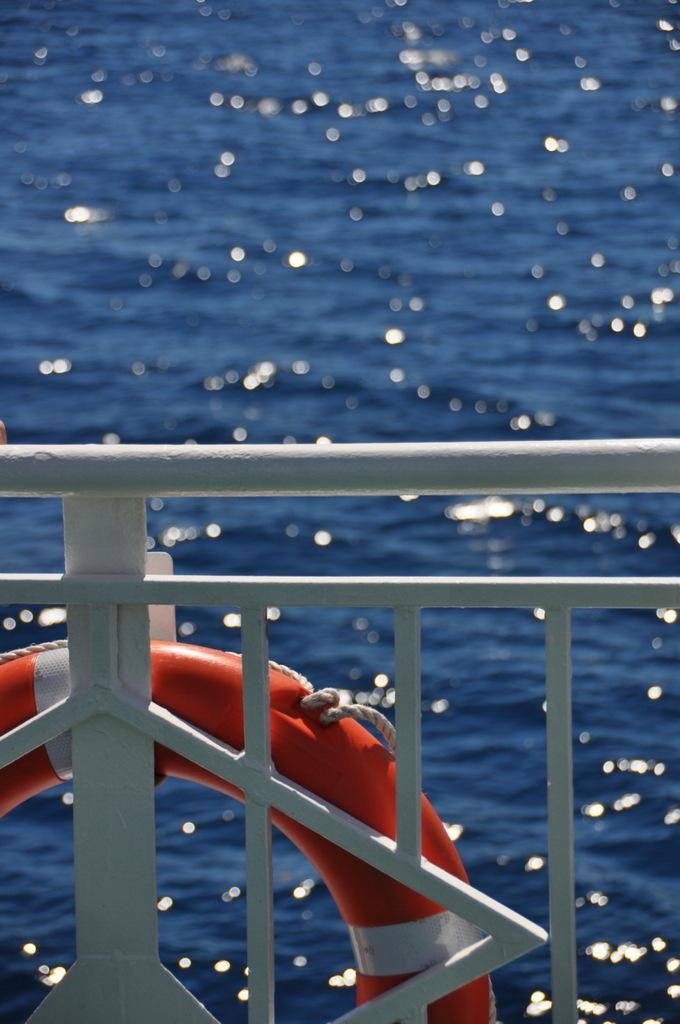Could you give a brief overview of what you see in this image? In this image there is a railing and a ring is hanging on it. In the background there is a river. 